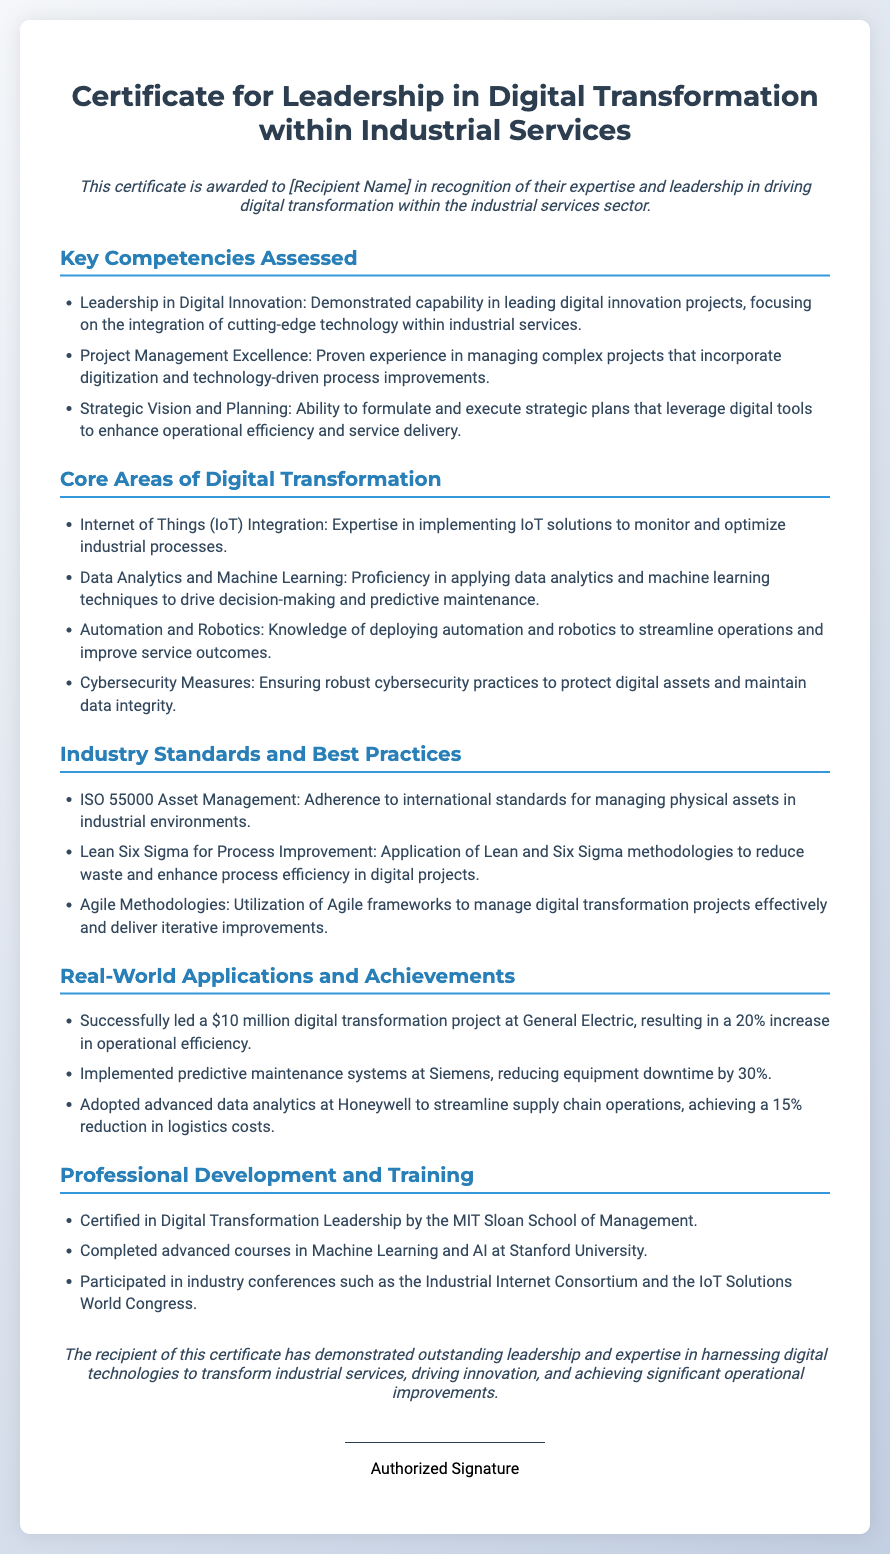What is the title of the certificate? The title of the certificate is presented at the top of the document.
Answer: Certificate for Leadership in Digital Transformation within Industrial Services Who is the certificate awarded to? The document states "[Recipient Name]" in the introduction section.
Answer: [Recipient Name] What percentage increase in operational efficiency was achieved at General Electric? The document provides the result of the digital transformation project at General Electric.
Answer: 20% What international standard is mentioned in the industry standards section? The document lists "ISO 55000 Asset Management" as an adhered standard.
Answer: ISO 55000 Asset Management Which advanced courses were completed at Stanford University? The document specifies the completion of "advanced courses in Machine Learning and AI" as part of professional development.
Answer: Machine Learning and AI What project management methodology is mentioned in the industry standards? The document notes "Agile Methodologies" as a methodology utilized in digital transformation projects.
Answer: Agile Methodologies Which company experienced a 30% reduction in equipment downtime? The document states the achievement related to predictive maintenance systems at Siemens.
Answer: Siemens What is one core area of digital transformation listed? The document outlines several areas, including “Data Analytics and Machine Learning.”
Answer: Data Analytics and Machine Learning 